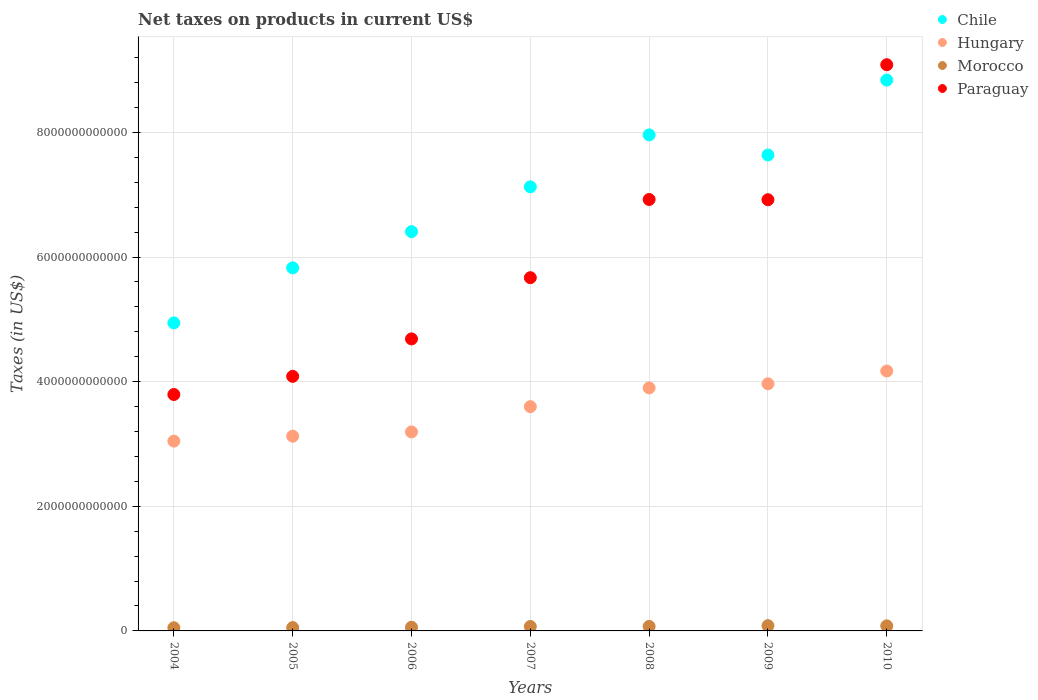Is the number of dotlines equal to the number of legend labels?
Ensure brevity in your answer.  Yes. What is the net taxes on products in Paraguay in 2007?
Offer a terse response. 5.67e+12. Across all years, what is the maximum net taxes on products in Morocco?
Give a very brief answer. 8.40e+1. Across all years, what is the minimum net taxes on products in Hungary?
Your response must be concise. 3.05e+12. What is the total net taxes on products in Paraguay in the graph?
Offer a very short reply. 4.12e+13. What is the difference between the net taxes on products in Hungary in 2004 and that in 2008?
Offer a very short reply. -8.54e+11. What is the difference between the net taxes on products in Morocco in 2005 and the net taxes on products in Chile in 2007?
Provide a short and direct response. -7.07e+12. What is the average net taxes on products in Morocco per year?
Provide a short and direct response. 6.75e+1. In the year 2008, what is the difference between the net taxes on products in Paraguay and net taxes on products in Hungary?
Ensure brevity in your answer.  3.02e+12. What is the ratio of the net taxes on products in Chile in 2006 to that in 2010?
Ensure brevity in your answer.  0.72. Is the difference between the net taxes on products in Paraguay in 2004 and 2007 greater than the difference between the net taxes on products in Hungary in 2004 and 2007?
Your answer should be very brief. No. What is the difference between the highest and the second highest net taxes on products in Hungary?
Make the answer very short. 2.05e+11. What is the difference between the highest and the lowest net taxes on products in Morocco?
Provide a succinct answer. 3.33e+1. In how many years, is the net taxes on products in Chile greater than the average net taxes on products in Chile taken over all years?
Give a very brief answer. 4. Is the sum of the net taxes on products in Morocco in 2008 and 2010 greater than the maximum net taxes on products in Paraguay across all years?
Offer a terse response. No. Is it the case that in every year, the sum of the net taxes on products in Chile and net taxes on products in Morocco  is greater than the sum of net taxes on products in Hungary and net taxes on products in Paraguay?
Your answer should be compact. No. Is it the case that in every year, the sum of the net taxes on products in Morocco and net taxes on products in Chile  is greater than the net taxes on products in Paraguay?
Your response must be concise. No. Does the net taxes on products in Paraguay monotonically increase over the years?
Offer a terse response. No. Is the net taxes on products in Paraguay strictly less than the net taxes on products in Hungary over the years?
Your answer should be very brief. No. How many dotlines are there?
Keep it short and to the point. 4. How many years are there in the graph?
Give a very brief answer. 7. What is the difference between two consecutive major ticks on the Y-axis?
Your answer should be compact. 2.00e+12. Does the graph contain any zero values?
Give a very brief answer. No. How are the legend labels stacked?
Your answer should be compact. Vertical. What is the title of the graph?
Ensure brevity in your answer.  Net taxes on products in current US$. What is the label or title of the Y-axis?
Your answer should be very brief. Taxes (in US$). What is the Taxes (in US$) of Chile in 2004?
Provide a short and direct response. 4.94e+12. What is the Taxes (in US$) in Hungary in 2004?
Your answer should be compact. 3.05e+12. What is the Taxes (in US$) in Morocco in 2004?
Your answer should be very brief. 5.07e+1. What is the Taxes (in US$) of Paraguay in 2004?
Keep it short and to the point. 3.79e+12. What is the Taxes (in US$) of Chile in 2005?
Your response must be concise. 5.83e+12. What is the Taxes (in US$) in Hungary in 2005?
Your response must be concise. 3.12e+12. What is the Taxes (in US$) of Morocco in 2005?
Provide a short and direct response. 5.37e+1. What is the Taxes (in US$) in Paraguay in 2005?
Offer a very short reply. 4.08e+12. What is the Taxes (in US$) in Chile in 2006?
Make the answer very short. 6.41e+12. What is the Taxes (in US$) in Hungary in 2006?
Your answer should be very brief. 3.19e+12. What is the Taxes (in US$) of Morocco in 2006?
Your answer should be compact. 5.94e+1. What is the Taxes (in US$) of Paraguay in 2006?
Offer a very short reply. 4.69e+12. What is the Taxes (in US$) in Chile in 2007?
Your answer should be compact. 7.13e+12. What is the Taxes (in US$) of Hungary in 2007?
Keep it short and to the point. 3.60e+12. What is the Taxes (in US$) of Morocco in 2007?
Your response must be concise. 7.09e+1. What is the Taxes (in US$) in Paraguay in 2007?
Your response must be concise. 5.67e+12. What is the Taxes (in US$) in Chile in 2008?
Make the answer very short. 7.96e+12. What is the Taxes (in US$) of Hungary in 2008?
Your answer should be compact. 3.90e+12. What is the Taxes (in US$) in Morocco in 2008?
Give a very brief answer. 7.20e+1. What is the Taxes (in US$) of Paraguay in 2008?
Your answer should be compact. 6.92e+12. What is the Taxes (in US$) of Chile in 2009?
Your answer should be compact. 7.64e+12. What is the Taxes (in US$) in Hungary in 2009?
Your answer should be compact. 3.97e+12. What is the Taxes (in US$) in Morocco in 2009?
Your answer should be compact. 8.40e+1. What is the Taxes (in US$) in Paraguay in 2009?
Offer a very short reply. 6.92e+12. What is the Taxes (in US$) in Chile in 2010?
Your answer should be very brief. 8.84e+12. What is the Taxes (in US$) of Hungary in 2010?
Your answer should be compact. 4.17e+12. What is the Taxes (in US$) of Morocco in 2010?
Ensure brevity in your answer.  8.13e+1. What is the Taxes (in US$) in Paraguay in 2010?
Your response must be concise. 9.09e+12. Across all years, what is the maximum Taxes (in US$) of Chile?
Provide a short and direct response. 8.84e+12. Across all years, what is the maximum Taxes (in US$) in Hungary?
Offer a terse response. 4.17e+12. Across all years, what is the maximum Taxes (in US$) of Morocco?
Provide a short and direct response. 8.40e+1. Across all years, what is the maximum Taxes (in US$) in Paraguay?
Offer a very short reply. 9.09e+12. Across all years, what is the minimum Taxes (in US$) of Chile?
Offer a terse response. 4.94e+12. Across all years, what is the minimum Taxes (in US$) in Hungary?
Your answer should be compact. 3.05e+12. Across all years, what is the minimum Taxes (in US$) of Morocco?
Keep it short and to the point. 5.07e+1. Across all years, what is the minimum Taxes (in US$) of Paraguay?
Offer a very short reply. 3.79e+12. What is the total Taxes (in US$) in Chile in the graph?
Your response must be concise. 4.87e+13. What is the total Taxes (in US$) of Hungary in the graph?
Your answer should be very brief. 2.50e+13. What is the total Taxes (in US$) of Morocco in the graph?
Offer a very short reply. 4.72e+11. What is the total Taxes (in US$) of Paraguay in the graph?
Make the answer very short. 4.12e+13. What is the difference between the Taxes (in US$) of Chile in 2004 and that in 2005?
Offer a terse response. -8.84e+11. What is the difference between the Taxes (in US$) of Hungary in 2004 and that in 2005?
Make the answer very short. -7.94e+1. What is the difference between the Taxes (in US$) of Morocco in 2004 and that in 2005?
Provide a short and direct response. -2.99e+09. What is the difference between the Taxes (in US$) of Paraguay in 2004 and that in 2005?
Provide a succinct answer. -2.91e+11. What is the difference between the Taxes (in US$) of Chile in 2004 and that in 2006?
Provide a succinct answer. -1.46e+12. What is the difference between the Taxes (in US$) of Hungary in 2004 and that in 2006?
Provide a succinct answer. -1.48e+11. What is the difference between the Taxes (in US$) in Morocco in 2004 and that in 2006?
Keep it short and to the point. -8.66e+09. What is the difference between the Taxes (in US$) in Paraguay in 2004 and that in 2006?
Offer a very short reply. -8.92e+11. What is the difference between the Taxes (in US$) of Chile in 2004 and that in 2007?
Your answer should be very brief. -2.18e+12. What is the difference between the Taxes (in US$) in Hungary in 2004 and that in 2007?
Make the answer very short. -5.53e+11. What is the difference between the Taxes (in US$) of Morocco in 2004 and that in 2007?
Make the answer very short. -2.02e+1. What is the difference between the Taxes (in US$) of Paraguay in 2004 and that in 2007?
Your response must be concise. -1.87e+12. What is the difference between the Taxes (in US$) of Chile in 2004 and that in 2008?
Keep it short and to the point. -3.02e+12. What is the difference between the Taxes (in US$) of Hungary in 2004 and that in 2008?
Keep it short and to the point. -8.54e+11. What is the difference between the Taxes (in US$) in Morocco in 2004 and that in 2008?
Keep it short and to the point. -2.13e+1. What is the difference between the Taxes (in US$) in Paraguay in 2004 and that in 2008?
Provide a succinct answer. -3.13e+12. What is the difference between the Taxes (in US$) in Chile in 2004 and that in 2009?
Offer a very short reply. -2.69e+12. What is the difference between the Taxes (in US$) of Hungary in 2004 and that in 2009?
Your answer should be very brief. -9.20e+11. What is the difference between the Taxes (in US$) of Morocco in 2004 and that in 2009?
Your answer should be compact. -3.33e+1. What is the difference between the Taxes (in US$) in Paraguay in 2004 and that in 2009?
Ensure brevity in your answer.  -3.13e+12. What is the difference between the Taxes (in US$) of Chile in 2004 and that in 2010?
Your answer should be very brief. -3.90e+12. What is the difference between the Taxes (in US$) in Hungary in 2004 and that in 2010?
Offer a very short reply. -1.13e+12. What is the difference between the Taxes (in US$) of Morocco in 2004 and that in 2010?
Make the answer very short. -3.06e+1. What is the difference between the Taxes (in US$) in Paraguay in 2004 and that in 2010?
Provide a succinct answer. -5.29e+12. What is the difference between the Taxes (in US$) in Chile in 2005 and that in 2006?
Ensure brevity in your answer.  -5.81e+11. What is the difference between the Taxes (in US$) in Hungary in 2005 and that in 2006?
Provide a succinct answer. -6.83e+1. What is the difference between the Taxes (in US$) of Morocco in 2005 and that in 2006?
Your response must be concise. -5.67e+09. What is the difference between the Taxes (in US$) in Paraguay in 2005 and that in 2006?
Your response must be concise. -6.01e+11. What is the difference between the Taxes (in US$) of Chile in 2005 and that in 2007?
Your response must be concise. -1.30e+12. What is the difference between the Taxes (in US$) in Hungary in 2005 and that in 2007?
Provide a succinct answer. -4.74e+11. What is the difference between the Taxes (in US$) of Morocco in 2005 and that in 2007?
Your answer should be compact. -1.72e+1. What is the difference between the Taxes (in US$) of Paraguay in 2005 and that in 2007?
Make the answer very short. -1.58e+12. What is the difference between the Taxes (in US$) of Chile in 2005 and that in 2008?
Give a very brief answer. -2.13e+12. What is the difference between the Taxes (in US$) of Hungary in 2005 and that in 2008?
Your response must be concise. -7.75e+11. What is the difference between the Taxes (in US$) of Morocco in 2005 and that in 2008?
Give a very brief answer. -1.83e+1. What is the difference between the Taxes (in US$) in Paraguay in 2005 and that in 2008?
Give a very brief answer. -2.84e+12. What is the difference between the Taxes (in US$) of Chile in 2005 and that in 2009?
Your response must be concise. -1.81e+12. What is the difference between the Taxes (in US$) of Hungary in 2005 and that in 2009?
Offer a terse response. -8.41e+11. What is the difference between the Taxes (in US$) of Morocco in 2005 and that in 2009?
Your answer should be very brief. -3.03e+1. What is the difference between the Taxes (in US$) in Paraguay in 2005 and that in 2009?
Provide a short and direct response. -2.83e+12. What is the difference between the Taxes (in US$) in Chile in 2005 and that in 2010?
Offer a very short reply. -3.01e+12. What is the difference between the Taxes (in US$) of Hungary in 2005 and that in 2010?
Ensure brevity in your answer.  -1.05e+12. What is the difference between the Taxes (in US$) in Morocco in 2005 and that in 2010?
Your response must be concise. -2.76e+1. What is the difference between the Taxes (in US$) in Paraguay in 2005 and that in 2010?
Provide a succinct answer. -5.00e+12. What is the difference between the Taxes (in US$) in Chile in 2006 and that in 2007?
Give a very brief answer. -7.18e+11. What is the difference between the Taxes (in US$) of Hungary in 2006 and that in 2007?
Offer a very short reply. -4.06e+11. What is the difference between the Taxes (in US$) in Morocco in 2006 and that in 2007?
Keep it short and to the point. -1.15e+1. What is the difference between the Taxes (in US$) of Paraguay in 2006 and that in 2007?
Your answer should be compact. -9.82e+11. What is the difference between the Taxes (in US$) in Chile in 2006 and that in 2008?
Your response must be concise. -1.55e+12. What is the difference between the Taxes (in US$) in Hungary in 2006 and that in 2008?
Your response must be concise. -7.06e+11. What is the difference between the Taxes (in US$) in Morocco in 2006 and that in 2008?
Give a very brief answer. -1.27e+1. What is the difference between the Taxes (in US$) in Paraguay in 2006 and that in 2008?
Ensure brevity in your answer.  -2.24e+12. What is the difference between the Taxes (in US$) in Chile in 2006 and that in 2009?
Offer a very short reply. -1.23e+12. What is the difference between the Taxes (in US$) of Hungary in 2006 and that in 2009?
Keep it short and to the point. -7.73e+11. What is the difference between the Taxes (in US$) of Morocco in 2006 and that in 2009?
Your answer should be compact. -2.46e+1. What is the difference between the Taxes (in US$) in Paraguay in 2006 and that in 2009?
Give a very brief answer. -2.23e+12. What is the difference between the Taxes (in US$) in Chile in 2006 and that in 2010?
Keep it short and to the point. -2.43e+12. What is the difference between the Taxes (in US$) of Hungary in 2006 and that in 2010?
Your answer should be very brief. -9.78e+11. What is the difference between the Taxes (in US$) in Morocco in 2006 and that in 2010?
Your answer should be compact. -2.19e+1. What is the difference between the Taxes (in US$) in Paraguay in 2006 and that in 2010?
Your answer should be very brief. -4.40e+12. What is the difference between the Taxes (in US$) in Chile in 2007 and that in 2008?
Keep it short and to the point. -8.34e+11. What is the difference between the Taxes (in US$) of Hungary in 2007 and that in 2008?
Provide a succinct answer. -3.01e+11. What is the difference between the Taxes (in US$) in Morocco in 2007 and that in 2008?
Your answer should be very brief. -1.14e+09. What is the difference between the Taxes (in US$) in Paraguay in 2007 and that in 2008?
Provide a short and direct response. -1.25e+12. What is the difference between the Taxes (in US$) of Chile in 2007 and that in 2009?
Your answer should be compact. -5.11e+11. What is the difference between the Taxes (in US$) in Hungary in 2007 and that in 2009?
Offer a terse response. -3.67e+11. What is the difference between the Taxes (in US$) of Morocco in 2007 and that in 2009?
Provide a short and direct response. -1.31e+1. What is the difference between the Taxes (in US$) in Paraguay in 2007 and that in 2009?
Your answer should be compact. -1.25e+12. What is the difference between the Taxes (in US$) of Chile in 2007 and that in 2010?
Ensure brevity in your answer.  -1.71e+12. What is the difference between the Taxes (in US$) in Hungary in 2007 and that in 2010?
Provide a short and direct response. -5.72e+11. What is the difference between the Taxes (in US$) in Morocco in 2007 and that in 2010?
Give a very brief answer. -1.04e+1. What is the difference between the Taxes (in US$) of Paraguay in 2007 and that in 2010?
Give a very brief answer. -3.42e+12. What is the difference between the Taxes (in US$) of Chile in 2008 and that in 2009?
Offer a terse response. 3.23e+11. What is the difference between the Taxes (in US$) of Hungary in 2008 and that in 2009?
Keep it short and to the point. -6.61e+1. What is the difference between the Taxes (in US$) in Morocco in 2008 and that in 2009?
Provide a succinct answer. -1.20e+1. What is the difference between the Taxes (in US$) in Paraguay in 2008 and that in 2009?
Provide a short and direct response. 3.74e+09. What is the difference between the Taxes (in US$) in Chile in 2008 and that in 2010?
Provide a succinct answer. -8.79e+11. What is the difference between the Taxes (in US$) of Hungary in 2008 and that in 2010?
Offer a very short reply. -2.71e+11. What is the difference between the Taxes (in US$) in Morocco in 2008 and that in 2010?
Provide a short and direct response. -9.26e+09. What is the difference between the Taxes (in US$) of Paraguay in 2008 and that in 2010?
Your answer should be compact. -2.16e+12. What is the difference between the Taxes (in US$) of Chile in 2009 and that in 2010?
Provide a short and direct response. -1.20e+12. What is the difference between the Taxes (in US$) in Hungary in 2009 and that in 2010?
Give a very brief answer. -2.05e+11. What is the difference between the Taxes (in US$) in Morocco in 2009 and that in 2010?
Provide a short and direct response. 2.72e+09. What is the difference between the Taxes (in US$) in Paraguay in 2009 and that in 2010?
Make the answer very short. -2.17e+12. What is the difference between the Taxes (in US$) in Chile in 2004 and the Taxes (in US$) in Hungary in 2005?
Your answer should be compact. 1.82e+12. What is the difference between the Taxes (in US$) in Chile in 2004 and the Taxes (in US$) in Morocco in 2005?
Your answer should be compact. 4.89e+12. What is the difference between the Taxes (in US$) of Chile in 2004 and the Taxes (in US$) of Paraguay in 2005?
Make the answer very short. 8.58e+11. What is the difference between the Taxes (in US$) in Hungary in 2004 and the Taxes (in US$) in Morocco in 2005?
Your answer should be very brief. 2.99e+12. What is the difference between the Taxes (in US$) of Hungary in 2004 and the Taxes (in US$) of Paraguay in 2005?
Ensure brevity in your answer.  -1.04e+12. What is the difference between the Taxes (in US$) in Morocco in 2004 and the Taxes (in US$) in Paraguay in 2005?
Offer a very short reply. -4.03e+12. What is the difference between the Taxes (in US$) in Chile in 2004 and the Taxes (in US$) in Hungary in 2006?
Offer a terse response. 1.75e+12. What is the difference between the Taxes (in US$) of Chile in 2004 and the Taxes (in US$) of Morocco in 2006?
Offer a very short reply. 4.88e+12. What is the difference between the Taxes (in US$) in Chile in 2004 and the Taxes (in US$) in Paraguay in 2006?
Ensure brevity in your answer.  2.56e+11. What is the difference between the Taxes (in US$) of Hungary in 2004 and the Taxes (in US$) of Morocco in 2006?
Provide a succinct answer. 2.99e+12. What is the difference between the Taxes (in US$) in Hungary in 2004 and the Taxes (in US$) in Paraguay in 2006?
Your answer should be compact. -1.64e+12. What is the difference between the Taxes (in US$) in Morocco in 2004 and the Taxes (in US$) in Paraguay in 2006?
Provide a short and direct response. -4.64e+12. What is the difference between the Taxes (in US$) of Chile in 2004 and the Taxes (in US$) of Hungary in 2007?
Give a very brief answer. 1.34e+12. What is the difference between the Taxes (in US$) of Chile in 2004 and the Taxes (in US$) of Morocco in 2007?
Keep it short and to the point. 4.87e+12. What is the difference between the Taxes (in US$) of Chile in 2004 and the Taxes (in US$) of Paraguay in 2007?
Make the answer very short. -7.26e+11. What is the difference between the Taxes (in US$) in Hungary in 2004 and the Taxes (in US$) in Morocco in 2007?
Ensure brevity in your answer.  2.97e+12. What is the difference between the Taxes (in US$) of Hungary in 2004 and the Taxes (in US$) of Paraguay in 2007?
Ensure brevity in your answer.  -2.62e+12. What is the difference between the Taxes (in US$) in Morocco in 2004 and the Taxes (in US$) in Paraguay in 2007?
Ensure brevity in your answer.  -5.62e+12. What is the difference between the Taxes (in US$) of Chile in 2004 and the Taxes (in US$) of Hungary in 2008?
Provide a short and direct response. 1.04e+12. What is the difference between the Taxes (in US$) of Chile in 2004 and the Taxes (in US$) of Morocco in 2008?
Make the answer very short. 4.87e+12. What is the difference between the Taxes (in US$) in Chile in 2004 and the Taxes (in US$) in Paraguay in 2008?
Offer a very short reply. -1.98e+12. What is the difference between the Taxes (in US$) in Hungary in 2004 and the Taxes (in US$) in Morocco in 2008?
Offer a very short reply. 2.97e+12. What is the difference between the Taxes (in US$) of Hungary in 2004 and the Taxes (in US$) of Paraguay in 2008?
Give a very brief answer. -3.88e+12. What is the difference between the Taxes (in US$) of Morocco in 2004 and the Taxes (in US$) of Paraguay in 2008?
Provide a short and direct response. -6.87e+12. What is the difference between the Taxes (in US$) of Chile in 2004 and the Taxes (in US$) of Hungary in 2009?
Make the answer very short. 9.77e+11. What is the difference between the Taxes (in US$) in Chile in 2004 and the Taxes (in US$) in Morocco in 2009?
Ensure brevity in your answer.  4.86e+12. What is the difference between the Taxes (in US$) in Chile in 2004 and the Taxes (in US$) in Paraguay in 2009?
Ensure brevity in your answer.  -1.98e+12. What is the difference between the Taxes (in US$) in Hungary in 2004 and the Taxes (in US$) in Morocco in 2009?
Provide a succinct answer. 2.96e+12. What is the difference between the Taxes (in US$) in Hungary in 2004 and the Taxes (in US$) in Paraguay in 2009?
Provide a short and direct response. -3.87e+12. What is the difference between the Taxes (in US$) in Morocco in 2004 and the Taxes (in US$) in Paraguay in 2009?
Make the answer very short. -6.87e+12. What is the difference between the Taxes (in US$) of Chile in 2004 and the Taxes (in US$) of Hungary in 2010?
Provide a succinct answer. 7.72e+11. What is the difference between the Taxes (in US$) in Chile in 2004 and the Taxes (in US$) in Morocco in 2010?
Make the answer very short. 4.86e+12. What is the difference between the Taxes (in US$) of Chile in 2004 and the Taxes (in US$) of Paraguay in 2010?
Make the answer very short. -4.14e+12. What is the difference between the Taxes (in US$) in Hungary in 2004 and the Taxes (in US$) in Morocco in 2010?
Offer a very short reply. 2.96e+12. What is the difference between the Taxes (in US$) of Hungary in 2004 and the Taxes (in US$) of Paraguay in 2010?
Keep it short and to the point. -6.04e+12. What is the difference between the Taxes (in US$) of Morocco in 2004 and the Taxes (in US$) of Paraguay in 2010?
Your response must be concise. -9.03e+12. What is the difference between the Taxes (in US$) in Chile in 2005 and the Taxes (in US$) in Hungary in 2006?
Provide a succinct answer. 2.63e+12. What is the difference between the Taxes (in US$) of Chile in 2005 and the Taxes (in US$) of Morocco in 2006?
Your answer should be compact. 5.77e+12. What is the difference between the Taxes (in US$) in Chile in 2005 and the Taxes (in US$) in Paraguay in 2006?
Your response must be concise. 1.14e+12. What is the difference between the Taxes (in US$) of Hungary in 2005 and the Taxes (in US$) of Morocco in 2006?
Your answer should be very brief. 3.07e+12. What is the difference between the Taxes (in US$) in Hungary in 2005 and the Taxes (in US$) in Paraguay in 2006?
Your response must be concise. -1.56e+12. What is the difference between the Taxes (in US$) of Morocco in 2005 and the Taxes (in US$) of Paraguay in 2006?
Provide a short and direct response. -4.63e+12. What is the difference between the Taxes (in US$) in Chile in 2005 and the Taxes (in US$) in Hungary in 2007?
Provide a short and direct response. 2.23e+12. What is the difference between the Taxes (in US$) in Chile in 2005 and the Taxes (in US$) in Morocco in 2007?
Offer a terse response. 5.76e+12. What is the difference between the Taxes (in US$) in Chile in 2005 and the Taxes (in US$) in Paraguay in 2007?
Provide a short and direct response. 1.58e+11. What is the difference between the Taxes (in US$) of Hungary in 2005 and the Taxes (in US$) of Morocco in 2007?
Your answer should be compact. 3.05e+12. What is the difference between the Taxes (in US$) in Hungary in 2005 and the Taxes (in US$) in Paraguay in 2007?
Give a very brief answer. -2.54e+12. What is the difference between the Taxes (in US$) in Morocco in 2005 and the Taxes (in US$) in Paraguay in 2007?
Your answer should be very brief. -5.61e+12. What is the difference between the Taxes (in US$) of Chile in 2005 and the Taxes (in US$) of Hungary in 2008?
Ensure brevity in your answer.  1.93e+12. What is the difference between the Taxes (in US$) of Chile in 2005 and the Taxes (in US$) of Morocco in 2008?
Provide a succinct answer. 5.75e+12. What is the difference between the Taxes (in US$) in Chile in 2005 and the Taxes (in US$) in Paraguay in 2008?
Your answer should be compact. -1.10e+12. What is the difference between the Taxes (in US$) in Hungary in 2005 and the Taxes (in US$) in Morocco in 2008?
Make the answer very short. 3.05e+12. What is the difference between the Taxes (in US$) of Hungary in 2005 and the Taxes (in US$) of Paraguay in 2008?
Keep it short and to the point. -3.80e+12. What is the difference between the Taxes (in US$) of Morocco in 2005 and the Taxes (in US$) of Paraguay in 2008?
Provide a succinct answer. -6.87e+12. What is the difference between the Taxes (in US$) in Chile in 2005 and the Taxes (in US$) in Hungary in 2009?
Keep it short and to the point. 1.86e+12. What is the difference between the Taxes (in US$) of Chile in 2005 and the Taxes (in US$) of Morocco in 2009?
Your answer should be compact. 5.74e+12. What is the difference between the Taxes (in US$) of Chile in 2005 and the Taxes (in US$) of Paraguay in 2009?
Provide a short and direct response. -1.09e+12. What is the difference between the Taxes (in US$) in Hungary in 2005 and the Taxes (in US$) in Morocco in 2009?
Give a very brief answer. 3.04e+12. What is the difference between the Taxes (in US$) in Hungary in 2005 and the Taxes (in US$) in Paraguay in 2009?
Offer a terse response. -3.79e+12. What is the difference between the Taxes (in US$) in Morocco in 2005 and the Taxes (in US$) in Paraguay in 2009?
Provide a short and direct response. -6.87e+12. What is the difference between the Taxes (in US$) of Chile in 2005 and the Taxes (in US$) of Hungary in 2010?
Your response must be concise. 1.66e+12. What is the difference between the Taxes (in US$) in Chile in 2005 and the Taxes (in US$) in Morocco in 2010?
Provide a succinct answer. 5.75e+12. What is the difference between the Taxes (in US$) of Chile in 2005 and the Taxes (in US$) of Paraguay in 2010?
Provide a succinct answer. -3.26e+12. What is the difference between the Taxes (in US$) in Hungary in 2005 and the Taxes (in US$) in Morocco in 2010?
Provide a short and direct response. 3.04e+12. What is the difference between the Taxes (in US$) of Hungary in 2005 and the Taxes (in US$) of Paraguay in 2010?
Keep it short and to the point. -5.96e+12. What is the difference between the Taxes (in US$) in Morocco in 2005 and the Taxes (in US$) in Paraguay in 2010?
Your answer should be very brief. -9.03e+12. What is the difference between the Taxes (in US$) of Chile in 2006 and the Taxes (in US$) of Hungary in 2007?
Give a very brief answer. 2.81e+12. What is the difference between the Taxes (in US$) of Chile in 2006 and the Taxes (in US$) of Morocco in 2007?
Your answer should be compact. 6.34e+12. What is the difference between the Taxes (in US$) of Chile in 2006 and the Taxes (in US$) of Paraguay in 2007?
Your answer should be very brief. 7.39e+11. What is the difference between the Taxes (in US$) of Hungary in 2006 and the Taxes (in US$) of Morocco in 2007?
Provide a short and direct response. 3.12e+12. What is the difference between the Taxes (in US$) of Hungary in 2006 and the Taxes (in US$) of Paraguay in 2007?
Your answer should be very brief. -2.48e+12. What is the difference between the Taxes (in US$) in Morocco in 2006 and the Taxes (in US$) in Paraguay in 2007?
Offer a very short reply. -5.61e+12. What is the difference between the Taxes (in US$) in Chile in 2006 and the Taxes (in US$) in Hungary in 2008?
Give a very brief answer. 2.51e+12. What is the difference between the Taxes (in US$) in Chile in 2006 and the Taxes (in US$) in Morocco in 2008?
Offer a terse response. 6.34e+12. What is the difference between the Taxes (in US$) in Chile in 2006 and the Taxes (in US$) in Paraguay in 2008?
Offer a very short reply. -5.16e+11. What is the difference between the Taxes (in US$) of Hungary in 2006 and the Taxes (in US$) of Morocco in 2008?
Make the answer very short. 3.12e+12. What is the difference between the Taxes (in US$) of Hungary in 2006 and the Taxes (in US$) of Paraguay in 2008?
Give a very brief answer. -3.73e+12. What is the difference between the Taxes (in US$) in Morocco in 2006 and the Taxes (in US$) in Paraguay in 2008?
Keep it short and to the point. -6.86e+12. What is the difference between the Taxes (in US$) in Chile in 2006 and the Taxes (in US$) in Hungary in 2009?
Your answer should be very brief. 2.44e+12. What is the difference between the Taxes (in US$) of Chile in 2006 and the Taxes (in US$) of Morocco in 2009?
Your answer should be compact. 6.32e+12. What is the difference between the Taxes (in US$) in Chile in 2006 and the Taxes (in US$) in Paraguay in 2009?
Your answer should be compact. -5.12e+11. What is the difference between the Taxes (in US$) of Hungary in 2006 and the Taxes (in US$) of Morocco in 2009?
Ensure brevity in your answer.  3.11e+12. What is the difference between the Taxes (in US$) of Hungary in 2006 and the Taxes (in US$) of Paraguay in 2009?
Make the answer very short. -3.73e+12. What is the difference between the Taxes (in US$) of Morocco in 2006 and the Taxes (in US$) of Paraguay in 2009?
Offer a very short reply. -6.86e+12. What is the difference between the Taxes (in US$) in Chile in 2006 and the Taxes (in US$) in Hungary in 2010?
Offer a very short reply. 2.24e+12. What is the difference between the Taxes (in US$) in Chile in 2006 and the Taxes (in US$) in Morocco in 2010?
Make the answer very short. 6.33e+12. What is the difference between the Taxes (in US$) of Chile in 2006 and the Taxes (in US$) of Paraguay in 2010?
Give a very brief answer. -2.68e+12. What is the difference between the Taxes (in US$) of Hungary in 2006 and the Taxes (in US$) of Morocco in 2010?
Offer a terse response. 3.11e+12. What is the difference between the Taxes (in US$) in Hungary in 2006 and the Taxes (in US$) in Paraguay in 2010?
Your response must be concise. -5.89e+12. What is the difference between the Taxes (in US$) of Morocco in 2006 and the Taxes (in US$) of Paraguay in 2010?
Make the answer very short. -9.03e+12. What is the difference between the Taxes (in US$) of Chile in 2007 and the Taxes (in US$) of Hungary in 2008?
Your answer should be very brief. 3.23e+12. What is the difference between the Taxes (in US$) in Chile in 2007 and the Taxes (in US$) in Morocco in 2008?
Your answer should be compact. 7.05e+12. What is the difference between the Taxes (in US$) in Chile in 2007 and the Taxes (in US$) in Paraguay in 2008?
Offer a very short reply. 2.03e+11. What is the difference between the Taxes (in US$) in Hungary in 2007 and the Taxes (in US$) in Morocco in 2008?
Keep it short and to the point. 3.53e+12. What is the difference between the Taxes (in US$) in Hungary in 2007 and the Taxes (in US$) in Paraguay in 2008?
Ensure brevity in your answer.  -3.32e+12. What is the difference between the Taxes (in US$) of Morocco in 2007 and the Taxes (in US$) of Paraguay in 2008?
Provide a short and direct response. -6.85e+12. What is the difference between the Taxes (in US$) in Chile in 2007 and the Taxes (in US$) in Hungary in 2009?
Keep it short and to the point. 3.16e+12. What is the difference between the Taxes (in US$) in Chile in 2007 and the Taxes (in US$) in Morocco in 2009?
Ensure brevity in your answer.  7.04e+12. What is the difference between the Taxes (in US$) of Chile in 2007 and the Taxes (in US$) of Paraguay in 2009?
Offer a very short reply. 2.06e+11. What is the difference between the Taxes (in US$) in Hungary in 2007 and the Taxes (in US$) in Morocco in 2009?
Provide a short and direct response. 3.51e+12. What is the difference between the Taxes (in US$) in Hungary in 2007 and the Taxes (in US$) in Paraguay in 2009?
Give a very brief answer. -3.32e+12. What is the difference between the Taxes (in US$) in Morocco in 2007 and the Taxes (in US$) in Paraguay in 2009?
Keep it short and to the point. -6.85e+12. What is the difference between the Taxes (in US$) in Chile in 2007 and the Taxes (in US$) in Hungary in 2010?
Ensure brevity in your answer.  2.96e+12. What is the difference between the Taxes (in US$) in Chile in 2007 and the Taxes (in US$) in Morocco in 2010?
Make the answer very short. 7.04e+12. What is the difference between the Taxes (in US$) in Chile in 2007 and the Taxes (in US$) in Paraguay in 2010?
Offer a terse response. -1.96e+12. What is the difference between the Taxes (in US$) in Hungary in 2007 and the Taxes (in US$) in Morocco in 2010?
Provide a succinct answer. 3.52e+12. What is the difference between the Taxes (in US$) in Hungary in 2007 and the Taxes (in US$) in Paraguay in 2010?
Provide a short and direct response. -5.49e+12. What is the difference between the Taxes (in US$) in Morocco in 2007 and the Taxes (in US$) in Paraguay in 2010?
Provide a short and direct response. -9.01e+12. What is the difference between the Taxes (in US$) in Chile in 2008 and the Taxes (in US$) in Hungary in 2009?
Provide a succinct answer. 3.99e+12. What is the difference between the Taxes (in US$) of Chile in 2008 and the Taxes (in US$) of Morocco in 2009?
Your answer should be very brief. 7.88e+12. What is the difference between the Taxes (in US$) in Chile in 2008 and the Taxes (in US$) in Paraguay in 2009?
Keep it short and to the point. 1.04e+12. What is the difference between the Taxes (in US$) in Hungary in 2008 and the Taxes (in US$) in Morocco in 2009?
Ensure brevity in your answer.  3.82e+12. What is the difference between the Taxes (in US$) in Hungary in 2008 and the Taxes (in US$) in Paraguay in 2009?
Offer a very short reply. -3.02e+12. What is the difference between the Taxes (in US$) of Morocco in 2008 and the Taxes (in US$) of Paraguay in 2009?
Your answer should be very brief. -6.85e+12. What is the difference between the Taxes (in US$) of Chile in 2008 and the Taxes (in US$) of Hungary in 2010?
Offer a terse response. 3.79e+12. What is the difference between the Taxes (in US$) in Chile in 2008 and the Taxes (in US$) in Morocco in 2010?
Keep it short and to the point. 7.88e+12. What is the difference between the Taxes (in US$) of Chile in 2008 and the Taxes (in US$) of Paraguay in 2010?
Your response must be concise. -1.13e+12. What is the difference between the Taxes (in US$) in Hungary in 2008 and the Taxes (in US$) in Morocco in 2010?
Offer a terse response. 3.82e+12. What is the difference between the Taxes (in US$) of Hungary in 2008 and the Taxes (in US$) of Paraguay in 2010?
Your response must be concise. -5.19e+12. What is the difference between the Taxes (in US$) in Morocco in 2008 and the Taxes (in US$) in Paraguay in 2010?
Make the answer very short. -9.01e+12. What is the difference between the Taxes (in US$) of Chile in 2009 and the Taxes (in US$) of Hungary in 2010?
Your answer should be very brief. 3.47e+12. What is the difference between the Taxes (in US$) of Chile in 2009 and the Taxes (in US$) of Morocco in 2010?
Provide a short and direct response. 7.56e+12. What is the difference between the Taxes (in US$) in Chile in 2009 and the Taxes (in US$) in Paraguay in 2010?
Offer a very short reply. -1.45e+12. What is the difference between the Taxes (in US$) of Hungary in 2009 and the Taxes (in US$) of Morocco in 2010?
Your answer should be compact. 3.88e+12. What is the difference between the Taxes (in US$) of Hungary in 2009 and the Taxes (in US$) of Paraguay in 2010?
Your answer should be very brief. -5.12e+12. What is the difference between the Taxes (in US$) in Morocco in 2009 and the Taxes (in US$) in Paraguay in 2010?
Your answer should be very brief. -9.00e+12. What is the average Taxes (in US$) of Chile per year?
Your response must be concise. 6.96e+12. What is the average Taxes (in US$) of Hungary per year?
Provide a succinct answer. 3.57e+12. What is the average Taxes (in US$) in Morocco per year?
Make the answer very short. 6.75e+1. What is the average Taxes (in US$) in Paraguay per year?
Ensure brevity in your answer.  5.88e+12. In the year 2004, what is the difference between the Taxes (in US$) in Chile and Taxes (in US$) in Hungary?
Keep it short and to the point. 1.90e+12. In the year 2004, what is the difference between the Taxes (in US$) in Chile and Taxes (in US$) in Morocco?
Offer a terse response. 4.89e+12. In the year 2004, what is the difference between the Taxes (in US$) in Chile and Taxes (in US$) in Paraguay?
Your response must be concise. 1.15e+12. In the year 2004, what is the difference between the Taxes (in US$) of Hungary and Taxes (in US$) of Morocco?
Give a very brief answer. 2.99e+12. In the year 2004, what is the difference between the Taxes (in US$) in Hungary and Taxes (in US$) in Paraguay?
Your response must be concise. -7.48e+11. In the year 2004, what is the difference between the Taxes (in US$) in Morocco and Taxes (in US$) in Paraguay?
Offer a terse response. -3.74e+12. In the year 2005, what is the difference between the Taxes (in US$) in Chile and Taxes (in US$) in Hungary?
Ensure brevity in your answer.  2.70e+12. In the year 2005, what is the difference between the Taxes (in US$) of Chile and Taxes (in US$) of Morocco?
Provide a short and direct response. 5.77e+12. In the year 2005, what is the difference between the Taxes (in US$) of Chile and Taxes (in US$) of Paraguay?
Offer a terse response. 1.74e+12. In the year 2005, what is the difference between the Taxes (in US$) in Hungary and Taxes (in US$) in Morocco?
Your response must be concise. 3.07e+12. In the year 2005, what is the difference between the Taxes (in US$) in Hungary and Taxes (in US$) in Paraguay?
Offer a terse response. -9.60e+11. In the year 2005, what is the difference between the Taxes (in US$) of Morocco and Taxes (in US$) of Paraguay?
Your answer should be very brief. -4.03e+12. In the year 2006, what is the difference between the Taxes (in US$) in Chile and Taxes (in US$) in Hungary?
Make the answer very short. 3.21e+12. In the year 2006, what is the difference between the Taxes (in US$) of Chile and Taxes (in US$) of Morocco?
Ensure brevity in your answer.  6.35e+12. In the year 2006, what is the difference between the Taxes (in US$) in Chile and Taxes (in US$) in Paraguay?
Provide a short and direct response. 1.72e+12. In the year 2006, what is the difference between the Taxes (in US$) in Hungary and Taxes (in US$) in Morocco?
Your answer should be compact. 3.13e+12. In the year 2006, what is the difference between the Taxes (in US$) of Hungary and Taxes (in US$) of Paraguay?
Make the answer very short. -1.49e+12. In the year 2006, what is the difference between the Taxes (in US$) in Morocco and Taxes (in US$) in Paraguay?
Make the answer very short. -4.63e+12. In the year 2007, what is the difference between the Taxes (in US$) of Chile and Taxes (in US$) of Hungary?
Keep it short and to the point. 3.53e+12. In the year 2007, what is the difference between the Taxes (in US$) in Chile and Taxes (in US$) in Morocco?
Give a very brief answer. 7.05e+12. In the year 2007, what is the difference between the Taxes (in US$) of Chile and Taxes (in US$) of Paraguay?
Keep it short and to the point. 1.46e+12. In the year 2007, what is the difference between the Taxes (in US$) of Hungary and Taxes (in US$) of Morocco?
Make the answer very short. 3.53e+12. In the year 2007, what is the difference between the Taxes (in US$) in Hungary and Taxes (in US$) in Paraguay?
Your response must be concise. -2.07e+12. In the year 2007, what is the difference between the Taxes (in US$) of Morocco and Taxes (in US$) of Paraguay?
Your answer should be very brief. -5.60e+12. In the year 2008, what is the difference between the Taxes (in US$) in Chile and Taxes (in US$) in Hungary?
Your response must be concise. 4.06e+12. In the year 2008, what is the difference between the Taxes (in US$) in Chile and Taxes (in US$) in Morocco?
Give a very brief answer. 7.89e+12. In the year 2008, what is the difference between the Taxes (in US$) in Chile and Taxes (in US$) in Paraguay?
Ensure brevity in your answer.  1.04e+12. In the year 2008, what is the difference between the Taxes (in US$) of Hungary and Taxes (in US$) of Morocco?
Your answer should be very brief. 3.83e+12. In the year 2008, what is the difference between the Taxes (in US$) in Hungary and Taxes (in US$) in Paraguay?
Offer a very short reply. -3.02e+12. In the year 2008, what is the difference between the Taxes (in US$) in Morocco and Taxes (in US$) in Paraguay?
Your answer should be very brief. -6.85e+12. In the year 2009, what is the difference between the Taxes (in US$) in Chile and Taxes (in US$) in Hungary?
Make the answer very short. 3.67e+12. In the year 2009, what is the difference between the Taxes (in US$) in Chile and Taxes (in US$) in Morocco?
Keep it short and to the point. 7.55e+12. In the year 2009, what is the difference between the Taxes (in US$) of Chile and Taxes (in US$) of Paraguay?
Make the answer very short. 7.18e+11. In the year 2009, what is the difference between the Taxes (in US$) in Hungary and Taxes (in US$) in Morocco?
Your answer should be very brief. 3.88e+12. In the year 2009, what is the difference between the Taxes (in US$) of Hungary and Taxes (in US$) of Paraguay?
Offer a very short reply. -2.95e+12. In the year 2009, what is the difference between the Taxes (in US$) of Morocco and Taxes (in US$) of Paraguay?
Your answer should be very brief. -6.84e+12. In the year 2010, what is the difference between the Taxes (in US$) in Chile and Taxes (in US$) in Hungary?
Offer a terse response. 4.67e+12. In the year 2010, what is the difference between the Taxes (in US$) in Chile and Taxes (in US$) in Morocco?
Offer a terse response. 8.76e+12. In the year 2010, what is the difference between the Taxes (in US$) in Chile and Taxes (in US$) in Paraguay?
Your answer should be compact. -2.47e+11. In the year 2010, what is the difference between the Taxes (in US$) of Hungary and Taxes (in US$) of Morocco?
Offer a terse response. 4.09e+12. In the year 2010, what is the difference between the Taxes (in US$) of Hungary and Taxes (in US$) of Paraguay?
Make the answer very short. -4.91e+12. In the year 2010, what is the difference between the Taxes (in US$) in Morocco and Taxes (in US$) in Paraguay?
Your response must be concise. -9.00e+12. What is the ratio of the Taxes (in US$) in Chile in 2004 to that in 2005?
Your response must be concise. 0.85. What is the ratio of the Taxes (in US$) of Hungary in 2004 to that in 2005?
Your answer should be compact. 0.97. What is the ratio of the Taxes (in US$) of Morocco in 2004 to that in 2005?
Your answer should be compact. 0.94. What is the ratio of the Taxes (in US$) in Paraguay in 2004 to that in 2005?
Give a very brief answer. 0.93. What is the ratio of the Taxes (in US$) of Chile in 2004 to that in 2006?
Provide a short and direct response. 0.77. What is the ratio of the Taxes (in US$) of Hungary in 2004 to that in 2006?
Your response must be concise. 0.95. What is the ratio of the Taxes (in US$) of Morocco in 2004 to that in 2006?
Your answer should be very brief. 0.85. What is the ratio of the Taxes (in US$) of Paraguay in 2004 to that in 2006?
Offer a very short reply. 0.81. What is the ratio of the Taxes (in US$) in Chile in 2004 to that in 2007?
Give a very brief answer. 0.69. What is the ratio of the Taxes (in US$) of Hungary in 2004 to that in 2007?
Ensure brevity in your answer.  0.85. What is the ratio of the Taxes (in US$) of Morocco in 2004 to that in 2007?
Ensure brevity in your answer.  0.72. What is the ratio of the Taxes (in US$) in Paraguay in 2004 to that in 2007?
Ensure brevity in your answer.  0.67. What is the ratio of the Taxes (in US$) in Chile in 2004 to that in 2008?
Offer a terse response. 0.62. What is the ratio of the Taxes (in US$) of Hungary in 2004 to that in 2008?
Your answer should be very brief. 0.78. What is the ratio of the Taxes (in US$) in Morocco in 2004 to that in 2008?
Ensure brevity in your answer.  0.7. What is the ratio of the Taxes (in US$) of Paraguay in 2004 to that in 2008?
Offer a very short reply. 0.55. What is the ratio of the Taxes (in US$) in Chile in 2004 to that in 2009?
Keep it short and to the point. 0.65. What is the ratio of the Taxes (in US$) of Hungary in 2004 to that in 2009?
Offer a terse response. 0.77. What is the ratio of the Taxes (in US$) in Morocco in 2004 to that in 2009?
Keep it short and to the point. 0.6. What is the ratio of the Taxes (in US$) of Paraguay in 2004 to that in 2009?
Your answer should be very brief. 0.55. What is the ratio of the Taxes (in US$) in Chile in 2004 to that in 2010?
Give a very brief answer. 0.56. What is the ratio of the Taxes (in US$) in Hungary in 2004 to that in 2010?
Provide a short and direct response. 0.73. What is the ratio of the Taxes (in US$) in Morocco in 2004 to that in 2010?
Your answer should be compact. 0.62. What is the ratio of the Taxes (in US$) in Paraguay in 2004 to that in 2010?
Your response must be concise. 0.42. What is the ratio of the Taxes (in US$) of Chile in 2005 to that in 2006?
Provide a succinct answer. 0.91. What is the ratio of the Taxes (in US$) in Hungary in 2005 to that in 2006?
Provide a short and direct response. 0.98. What is the ratio of the Taxes (in US$) in Morocco in 2005 to that in 2006?
Make the answer very short. 0.9. What is the ratio of the Taxes (in US$) in Paraguay in 2005 to that in 2006?
Ensure brevity in your answer.  0.87. What is the ratio of the Taxes (in US$) of Chile in 2005 to that in 2007?
Keep it short and to the point. 0.82. What is the ratio of the Taxes (in US$) of Hungary in 2005 to that in 2007?
Offer a terse response. 0.87. What is the ratio of the Taxes (in US$) in Morocco in 2005 to that in 2007?
Your answer should be very brief. 0.76. What is the ratio of the Taxes (in US$) in Paraguay in 2005 to that in 2007?
Provide a succinct answer. 0.72. What is the ratio of the Taxes (in US$) in Chile in 2005 to that in 2008?
Offer a very short reply. 0.73. What is the ratio of the Taxes (in US$) of Hungary in 2005 to that in 2008?
Give a very brief answer. 0.8. What is the ratio of the Taxes (in US$) in Morocco in 2005 to that in 2008?
Your answer should be compact. 0.75. What is the ratio of the Taxes (in US$) of Paraguay in 2005 to that in 2008?
Make the answer very short. 0.59. What is the ratio of the Taxes (in US$) in Chile in 2005 to that in 2009?
Your answer should be very brief. 0.76. What is the ratio of the Taxes (in US$) of Hungary in 2005 to that in 2009?
Give a very brief answer. 0.79. What is the ratio of the Taxes (in US$) in Morocco in 2005 to that in 2009?
Offer a very short reply. 0.64. What is the ratio of the Taxes (in US$) of Paraguay in 2005 to that in 2009?
Your answer should be compact. 0.59. What is the ratio of the Taxes (in US$) in Chile in 2005 to that in 2010?
Provide a short and direct response. 0.66. What is the ratio of the Taxes (in US$) of Hungary in 2005 to that in 2010?
Your answer should be compact. 0.75. What is the ratio of the Taxes (in US$) of Morocco in 2005 to that in 2010?
Ensure brevity in your answer.  0.66. What is the ratio of the Taxes (in US$) in Paraguay in 2005 to that in 2010?
Provide a succinct answer. 0.45. What is the ratio of the Taxes (in US$) in Chile in 2006 to that in 2007?
Give a very brief answer. 0.9. What is the ratio of the Taxes (in US$) in Hungary in 2006 to that in 2007?
Make the answer very short. 0.89. What is the ratio of the Taxes (in US$) of Morocco in 2006 to that in 2007?
Make the answer very short. 0.84. What is the ratio of the Taxes (in US$) of Paraguay in 2006 to that in 2007?
Provide a short and direct response. 0.83. What is the ratio of the Taxes (in US$) in Chile in 2006 to that in 2008?
Your response must be concise. 0.81. What is the ratio of the Taxes (in US$) in Hungary in 2006 to that in 2008?
Provide a short and direct response. 0.82. What is the ratio of the Taxes (in US$) of Morocco in 2006 to that in 2008?
Offer a terse response. 0.82. What is the ratio of the Taxes (in US$) of Paraguay in 2006 to that in 2008?
Your answer should be very brief. 0.68. What is the ratio of the Taxes (in US$) of Chile in 2006 to that in 2009?
Offer a terse response. 0.84. What is the ratio of the Taxes (in US$) of Hungary in 2006 to that in 2009?
Give a very brief answer. 0.81. What is the ratio of the Taxes (in US$) in Morocco in 2006 to that in 2009?
Provide a succinct answer. 0.71. What is the ratio of the Taxes (in US$) in Paraguay in 2006 to that in 2009?
Give a very brief answer. 0.68. What is the ratio of the Taxes (in US$) in Chile in 2006 to that in 2010?
Provide a short and direct response. 0.72. What is the ratio of the Taxes (in US$) of Hungary in 2006 to that in 2010?
Offer a very short reply. 0.77. What is the ratio of the Taxes (in US$) in Morocco in 2006 to that in 2010?
Provide a short and direct response. 0.73. What is the ratio of the Taxes (in US$) of Paraguay in 2006 to that in 2010?
Provide a short and direct response. 0.52. What is the ratio of the Taxes (in US$) in Chile in 2007 to that in 2008?
Provide a succinct answer. 0.9. What is the ratio of the Taxes (in US$) of Hungary in 2007 to that in 2008?
Make the answer very short. 0.92. What is the ratio of the Taxes (in US$) of Morocco in 2007 to that in 2008?
Your answer should be compact. 0.98. What is the ratio of the Taxes (in US$) of Paraguay in 2007 to that in 2008?
Ensure brevity in your answer.  0.82. What is the ratio of the Taxes (in US$) of Chile in 2007 to that in 2009?
Offer a very short reply. 0.93. What is the ratio of the Taxes (in US$) of Hungary in 2007 to that in 2009?
Provide a short and direct response. 0.91. What is the ratio of the Taxes (in US$) in Morocco in 2007 to that in 2009?
Offer a very short reply. 0.84. What is the ratio of the Taxes (in US$) in Paraguay in 2007 to that in 2009?
Offer a terse response. 0.82. What is the ratio of the Taxes (in US$) in Chile in 2007 to that in 2010?
Your answer should be compact. 0.81. What is the ratio of the Taxes (in US$) in Hungary in 2007 to that in 2010?
Offer a terse response. 0.86. What is the ratio of the Taxes (in US$) of Morocco in 2007 to that in 2010?
Your answer should be compact. 0.87. What is the ratio of the Taxes (in US$) in Paraguay in 2007 to that in 2010?
Offer a terse response. 0.62. What is the ratio of the Taxes (in US$) in Chile in 2008 to that in 2009?
Your answer should be compact. 1.04. What is the ratio of the Taxes (in US$) in Hungary in 2008 to that in 2009?
Keep it short and to the point. 0.98. What is the ratio of the Taxes (in US$) in Morocco in 2008 to that in 2009?
Provide a succinct answer. 0.86. What is the ratio of the Taxes (in US$) of Chile in 2008 to that in 2010?
Your answer should be very brief. 0.9. What is the ratio of the Taxes (in US$) in Hungary in 2008 to that in 2010?
Make the answer very short. 0.94. What is the ratio of the Taxes (in US$) in Morocco in 2008 to that in 2010?
Give a very brief answer. 0.89. What is the ratio of the Taxes (in US$) in Paraguay in 2008 to that in 2010?
Offer a terse response. 0.76. What is the ratio of the Taxes (in US$) in Chile in 2009 to that in 2010?
Provide a short and direct response. 0.86. What is the ratio of the Taxes (in US$) in Hungary in 2009 to that in 2010?
Make the answer very short. 0.95. What is the ratio of the Taxes (in US$) of Morocco in 2009 to that in 2010?
Offer a very short reply. 1.03. What is the ratio of the Taxes (in US$) of Paraguay in 2009 to that in 2010?
Your response must be concise. 0.76. What is the difference between the highest and the second highest Taxes (in US$) of Chile?
Offer a terse response. 8.79e+11. What is the difference between the highest and the second highest Taxes (in US$) in Hungary?
Ensure brevity in your answer.  2.05e+11. What is the difference between the highest and the second highest Taxes (in US$) in Morocco?
Ensure brevity in your answer.  2.72e+09. What is the difference between the highest and the second highest Taxes (in US$) of Paraguay?
Provide a succinct answer. 2.16e+12. What is the difference between the highest and the lowest Taxes (in US$) in Chile?
Offer a terse response. 3.90e+12. What is the difference between the highest and the lowest Taxes (in US$) of Hungary?
Keep it short and to the point. 1.13e+12. What is the difference between the highest and the lowest Taxes (in US$) in Morocco?
Your answer should be very brief. 3.33e+1. What is the difference between the highest and the lowest Taxes (in US$) of Paraguay?
Provide a short and direct response. 5.29e+12. 